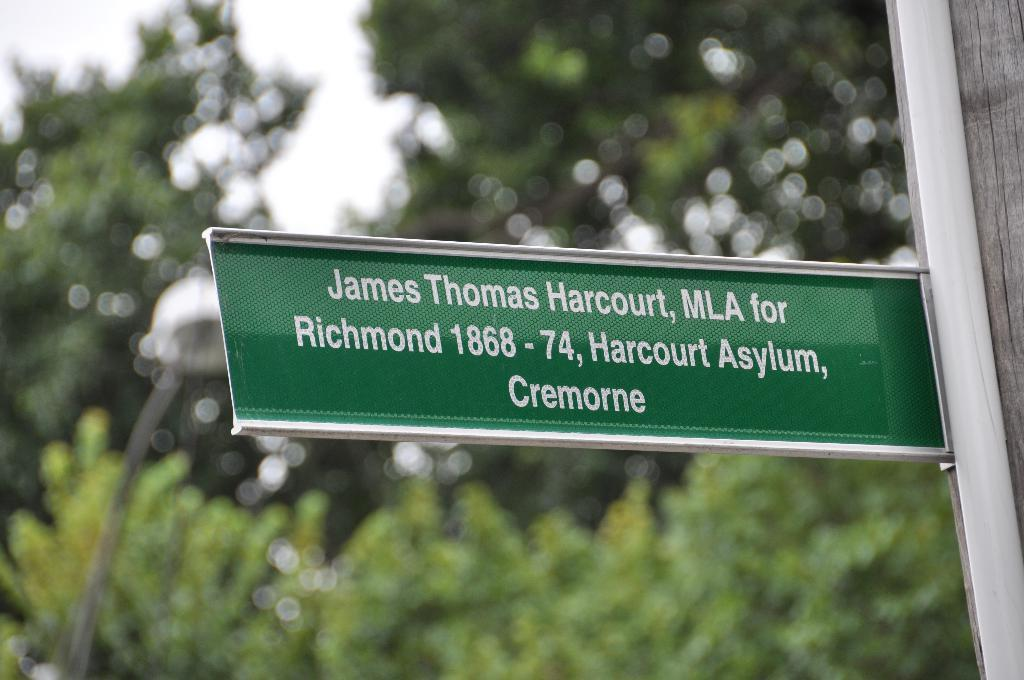What is the main object in the image? There is an address board in the image. How is the address board positioned in the image? The address board is attached to a pole. Can you describe the background of the address board? The background of the address board is blurry. What type of music can be heard playing in the background of the image? There is no music present in the image; it only features an address board attached to a pole. 